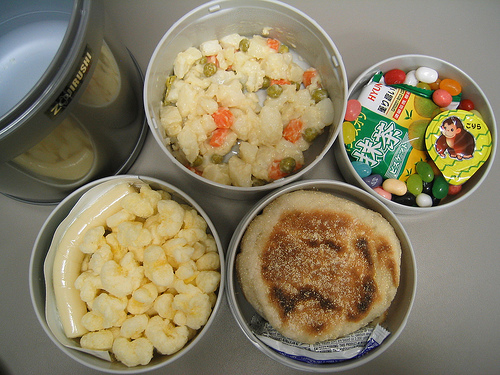<image>
Can you confirm if the pancake is on the pan? Yes. Looking at the image, I can see the pancake is positioned on top of the pan, with the pan providing support. 